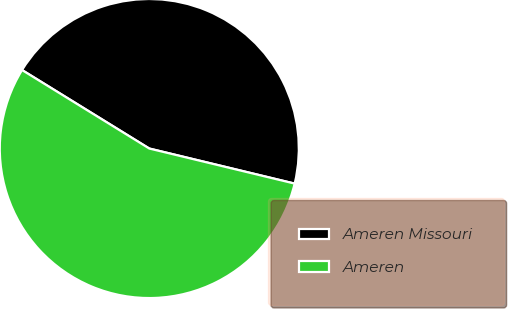Convert chart. <chart><loc_0><loc_0><loc_500><loc_500><pie_chart><fcel>Ameren Missouri<fcel>Ameren<nl><fcel>44.97%<fcel>55.03%<nl></chart> 